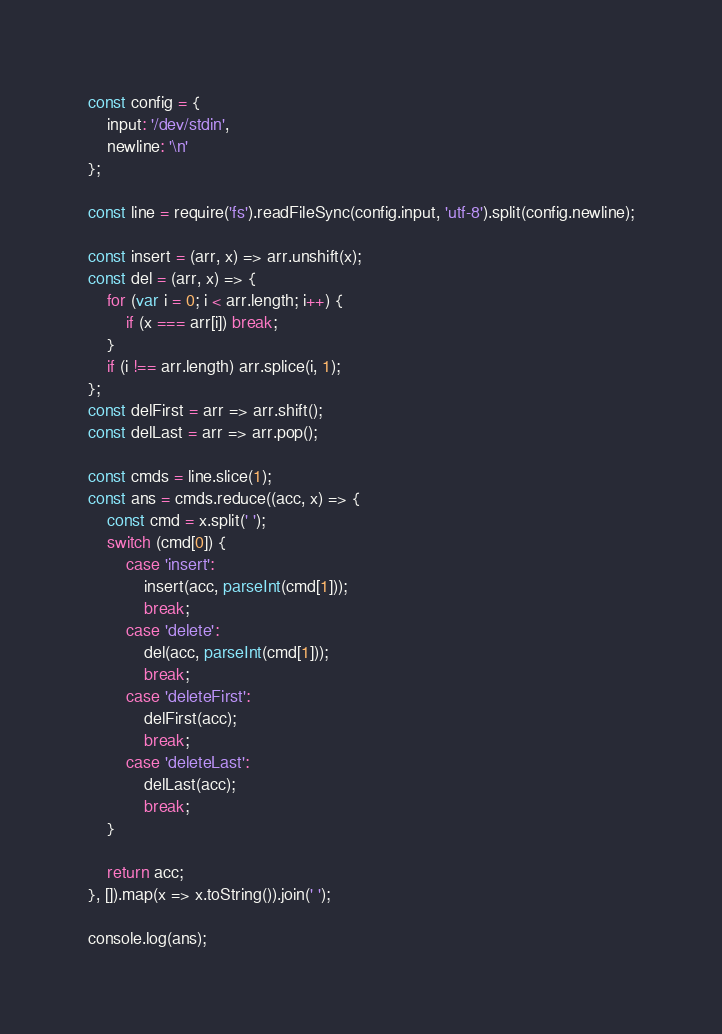Convert code to text. <code><loc_0><loc_0><loc_500><loc_500><_JavaScript_>const config = {
    input: '/dev/stdin',
    newline: '\n'
};

const line = require('fs').readFileSync(config.input, 'utf-8').split(config.newline);

const insert = (arr, x) => arr.unshift(x);
const del = (arr, x) => {
    for (var i = 0; i < arr.length; i++) {
        if (x === arr[i]) break;
    }
    if (i !== arr.length) arr.splice(i, 1);
};
const delFirst = arr => arr.shift();
const delLast = arr => arr.pop();

const cmds = line.slice(1);
const ans = cmds.reduce((acc, x) => {
    const cmd = x.split(' ');
    switch (cmd[0]) {
        case 'insert':
            insert(acc, parseInt(cmd[1]));
            break;
        case 'delete':
            del(acc, parseInt(cmd[1]));
            break;
        case 'deleteFirst':
            delFirst(acc);
            break;
        case 'deleteLast':
            delLast(acc);
            break;
    }

    return acc;
}, []).map(x => x.toString()).join(' ');

console.log(ans);

</code> 